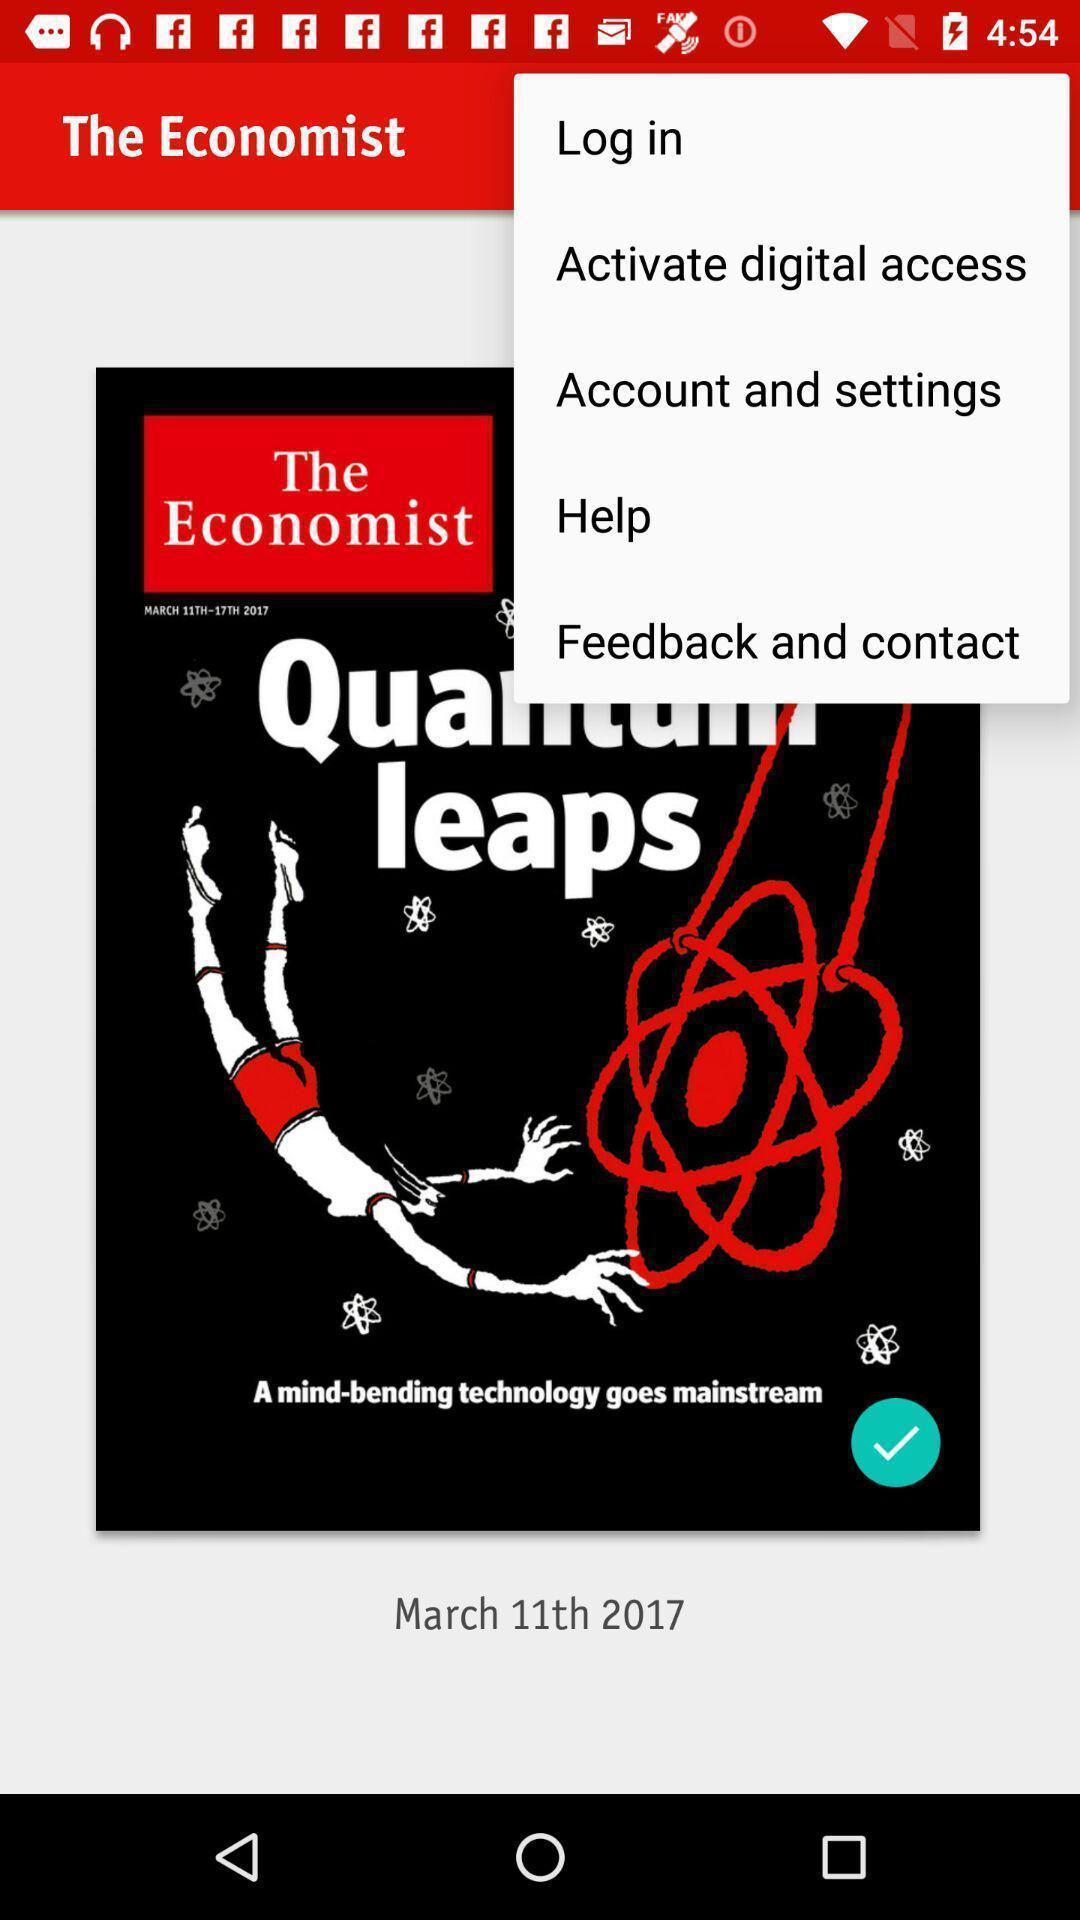Summarize the main components in this picture. Pop-up shows different options. 